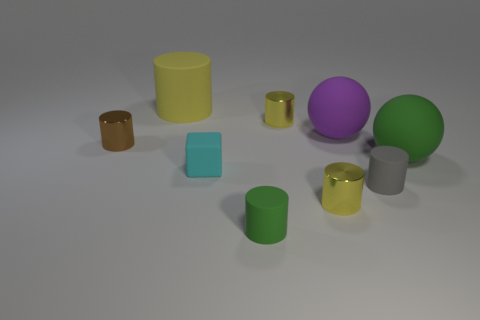Add 1 metallic cylinders. How many objects exist? 10 Subtract all green cylinders. How many cylinders are left? 5 Subtract all red spheres. How many yellow cylinders are left? 3 Subtract 6 cylinders. How many cylinders are left? 0 Subtract all gray cylinders. How many cylinders are left? 5 Subtract all cylinders. How many objects are left? 3 Add 4 rubber cubes. How many rubber cubes are left? 5 Add 2 big yellow matte spheres. How many big yellow matte spheres exist? 2 Subtract 1 cyan blocks. How many objects are left? 8 Subtract all blue cylinders. Subtract all purple balls. How many cylinders are left? 6 